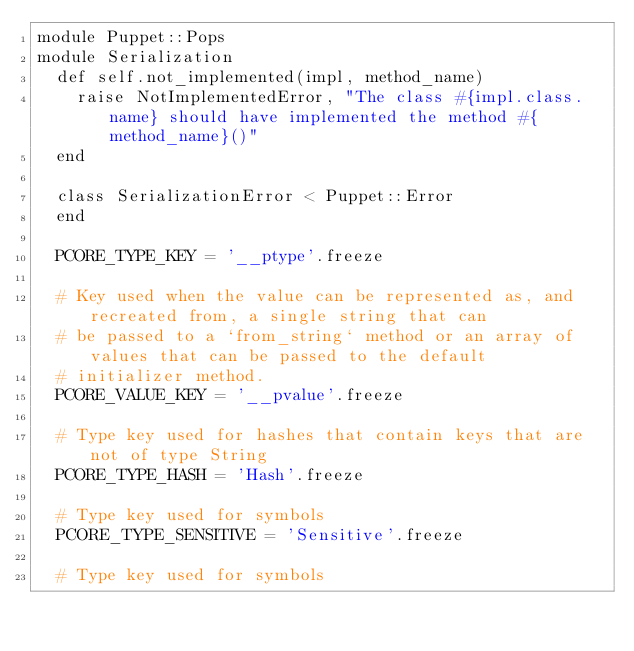Convert code to text. <code><loc_0><loc_0><loc_500><loc_500><_Ruby_>module Puppet::Pops
module Serialization
  def self.not_implemented(impl, method_name)
    raise NotImplementedError, "The class #{impl.class.name} should have implemented the method #{method_name}()"
  end

  class SerializationError < Puppet::Error
  end

  PCORE_TYPE_KEY = '__ptype'.freeze

  # Key used when the value can be represented as, and recreated from, a single string that can
  # be passed to a `from_string` method or an array of values that can be passed to the default
  # initializer method.
  PCORE_VALUE_KEY = '__pvalue'.freeze

  # Type key used for hashes that contain keys that are not of type String
  PCORE_TYPE_HASH = 'Hash'.freeze

  # Type key used for symbols
  PCORE_TYPE_SENSITIVE = 'Sensitive'.freeze

  # Type key used for symbols</code> 